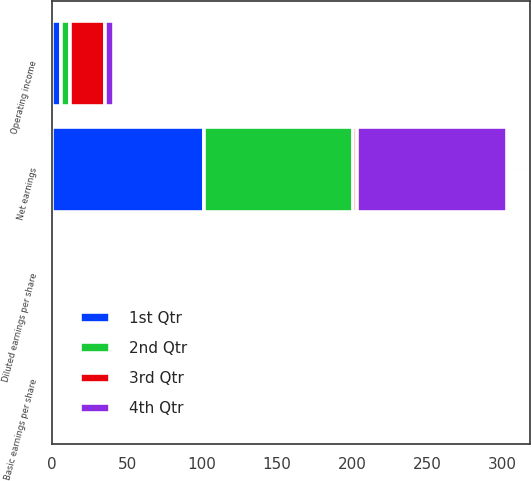Convert chart. <chart><loc_0><loc_0><loc_500><loc_500><stacked_bar_chart><ecel><fcel>Operating income<fcel>Net earnings<fcel>Basic earnings per share<fcel>Diluted earnings per share<nl><fcel>1st Qtr<fcel>6<fcel>101<fcel>0.58<fcel>0.58<nl><fcel>4th Qtr<fcel>6<fcel>100<fcel>0.57<fcel>0.57<nl><fcel>2nd Qtr<fcel>6<fcel>100<fcel>0.58<fcel>0.57<nl><fcel>3rd Qtr<fcel>23<fcel>2.29<fcel>2.29<fcel>2.28<nl></chart> 